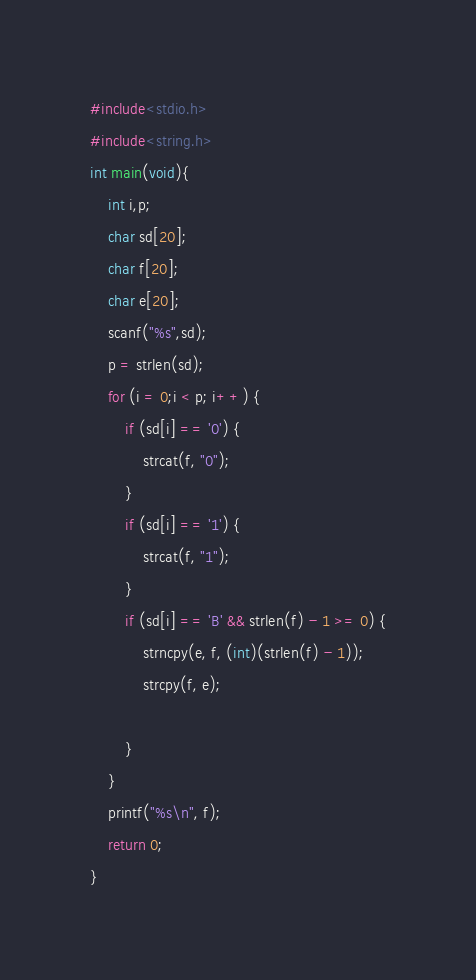<code> <loc_0><loc_0><loc_500><loc_500><_C_>#include<stdio.h>
#include<string.h>
int main(void){
	int i,p;
	char sd[20];
	char f[20];
	char e[20];
	scanf("%s",sd);
	p = strlen(sd);
	for (i = 0;i < p; i++) {
		if (sd[i] == '0') {
			strcat(f, "0");
		}
		if (sd[i] == '1') {
			strcat(f, "1");
		}
		if (sd[i] == 'B' && strlen(f) - 1 >= 0) {
		    strncpy(e, f, (int)(strlen(f) - 1));
			strcpy(f, e);
 
		}
	}
	printf("%s\n", f);
	return 0;
}</code> 